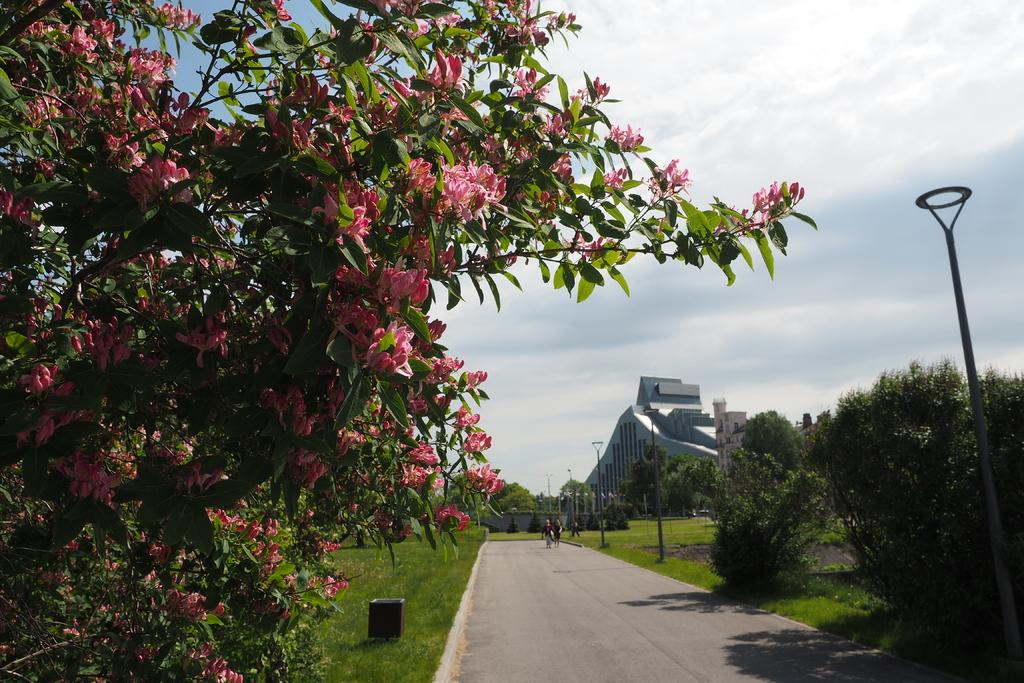What is located in the center of the image? There are trees in the center of the image. What else can be seen in the image besides the trees? There are persons, a building, flowers, a road, poles, the sky, and clouds visible in the image. Can you describe the type of structure in the image? There is a building in the image. What type of vegetation is present in the image? There are flowers in the image. What is the condition of the sky in the image? The sky is visible in the image, and there are clouds present. What type of bell can be heard ringing in the image? There is no bell present in the image, and therefore no sound can be heard. Can you describe the owl perched on the tree in the image? There is no owl present in the image; only trees, persons, a building, flowers, a road, poles, the sky, and clouds are visible. 